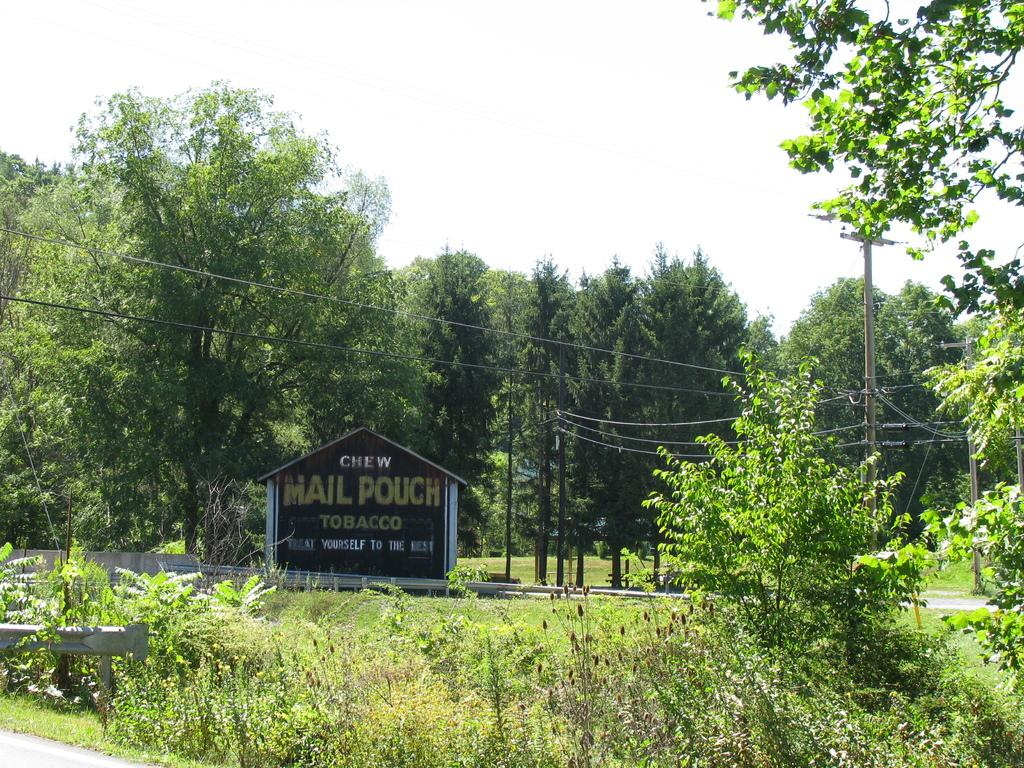What is placed on the ground in the image? There is a guard rail and a sign board placed on the ground in the image. What type of vegetation can be seen in the image? There is a group of plants and trees in the image. What can be seen in the background of the image? There is a group of poles, trees, and the sky visible in the background of the image. What type of underwear is hanging on the guard rail in the image? There is no underwear present in the image; it only features a guard rail, a sign board, plants, poles, trees, and the sky. How many thumbs can be seen interacting with the sign board in the image? There are no thumbs visible in the image, as it does not depict any human figures or hands. 